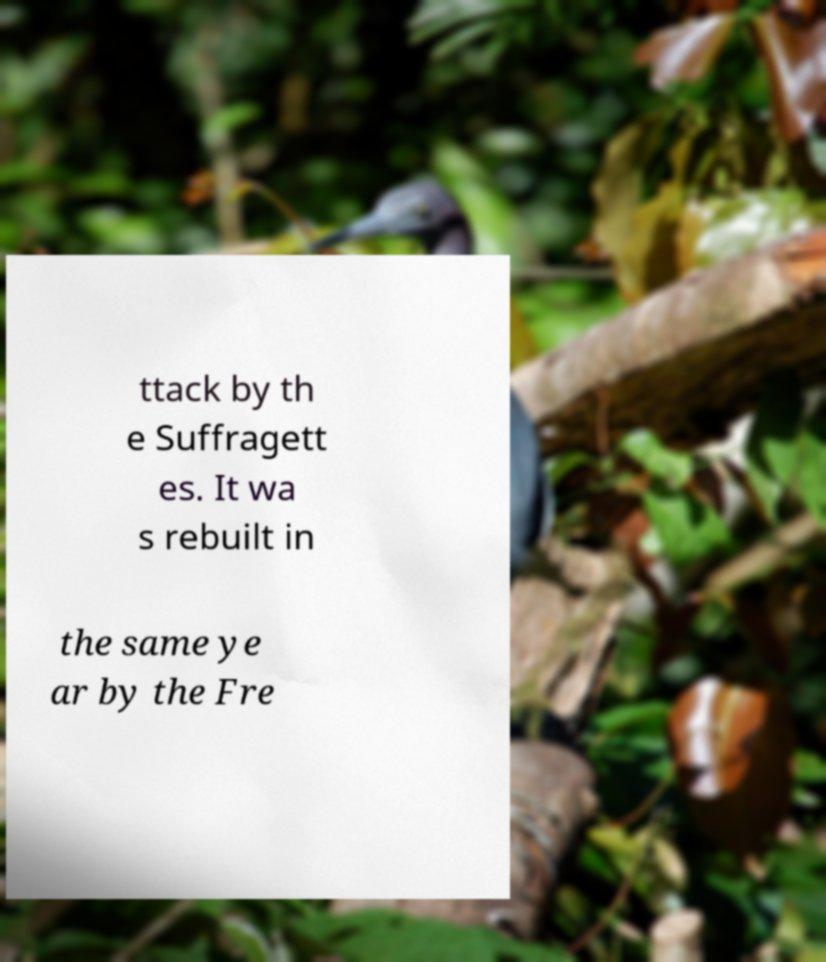I need the written content from this picture converted into text. Can you do that? ttack by th e Suffragett es. It wa s rebuilt in the same ye ar by the Fre 